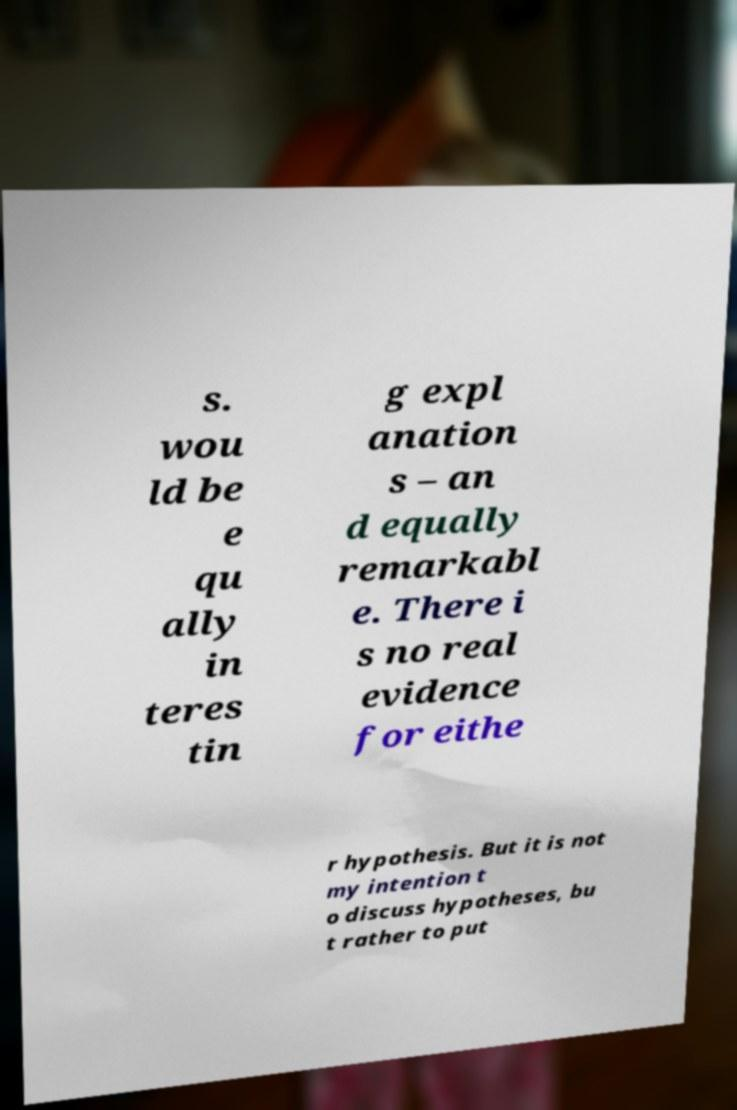What messages or text are displayed in this image? I need them in a readable, typed format. s. wou ld be e qu ally in teres tin g expl anation s – an d equally remarkabl e. There i s no real evidence for eithe r hypothesis. But it is not my intention t o discuss hypotheses, bu t rather to put 